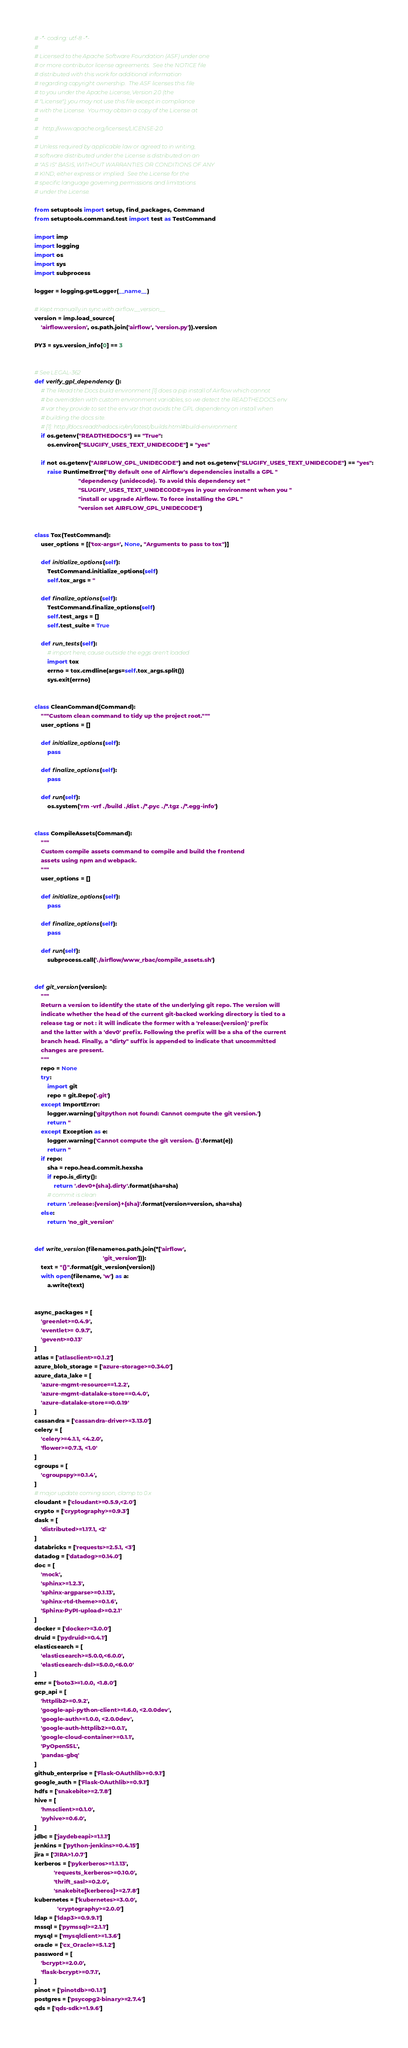<code> <loc_0><loc_0><loc_500><loc_500><_Python_># -*- coding: utf-8 -*-
#
# Licensed to the Apache Software Foundation (ASF) under one
# or more contributor license agreements.  See the NOTICE file
# distributed with this work for additional information
# regarding copyright ownership.  The ASF licenses this file
# to you under the Apache License, Version 2.0 (the
# "License"); you may not use this file except in compliance
# with the License.  You may obtain a copy of the License at
#
#   http://www.apache.org/licenses/LICENSE-2.0
#
# Unless required by applicable law or agreed to in writing,
# software distributed under the License is distributed on an
# "AS IS" BASIS, WITHOUT WARRANTIES OR CONDITIONS OF ANY
# KIND, either express or implied.  See the License for the
# specific language governing permissions and limitations
# under the License.

from setuptools import setup, find_packages, Command
from setuptools.command.test import test as TestCommand

import imp
import logging
import os
import sys
import subprocess

logger = logging.getLogger(__name__)

# Kept manually in sync with airflow.__version__
version = imp.load_source(
    'airflow.version', os.path.join('airflow', 'version.py')).version

PY3 = sys.version_info[0] == 3


# See LEGAL-362
def verify_gpl_dependency():
    # The Read the Docs build environment [1] does a pip install of Airflow which cannot
    # be overridden with custom environment variables, so we detect the READTHEDOCS env
    # var they provide to set the env var that avoids the GPL dependency on install when
    # building the docs site.
    # [1]: http://docs.readthedocs.io/en/latest/builds.html#build-environment
    if os.getenv("READTHEDOCS") == "True":
        os.environ["SLUGIFY_USES_TEXT_UNIDECODE"] = "yes"

    if not os.getenv("AIRFLOW_GPL_UNIDECODE") and not os.getenv("SLUGIFY_USES_TEXT_UNIDECODE") == "yes":
        raise RuntimeError("By default one of Airflow's dependencies installs a GPL "
                           "dependency (unidecode). To avoid this dependency set "
                           "SLUGIFY_USES_TEXT_UNIDECODE=yes in your environment when you "
                           "install or upgrade Airflow. To force installing the GPL "
                           "version set AIRFLOW_GPL_UNIDECODE")


class Tox(TestCommand):
    user_options = [('tox-args=', None, "Arguments to pass to tox")]

    def initialize_options(self):
        TestCommand.initialize_options(self)
        self.tox_args = ''

    def finalize_options(self):
        TestCommand.finalize_options(self)
        self.test_args = []
        self.test_suite = True

    def run_tests(self):
        # import here, cause outside the eggs aren't loaded
        import tox
        errno = tox.cmdline(args=self.tox_args.split())
        sys.exit(errno)


class CleanCommand(Command):
    """Custom clean command to tidy up the project root."""
    user_options = []

    def initialize_options(self):
        pass

    def finalize_options(self):
        pass

    def run(self):
        os.system('rm -vrf ./build ./dist ./*.pyc ./*.tgz ./*.egg-info')


class CompileAssets(Command):
    """
    Custom compile assets command to compile and build the frontend
    assets using npm and webpack.
    """
    user_options = []

    def initialize_options(self):
        pass

    def finalize_options(self):
        pass

    def run(self):
        subprocess.call('./airflow/www_rbac/compile_assets.sh')


def git_version(version):
    """
    Return a version to identify the state of the underlying git repo. The version will
    indicate whether the head of the current git-backed working directory is tied to a
    release tag or not : it will indicate the former with a 'release:{version}' prefix
    and the latter with a 'dev0' prefix. Following the prefix will be a sha of the current
    branch head. Finally, a "dirty" suffix is appended to indicate that uncommitted
    changes are present.
    """
    repo = None
    try:
        import git
        repo = git.Repo('.git')
    except ImportError:
        logger.warning('gitpython not found: Cannot compute the git version.')
        return ''
    except Exception as e:
        logger.warning('Cannot compute the git version. {}'.format(e))
        return ''
    if repo:
        sha = repo.head.commit.hexsha
        if repo.is_dirty():
            return '.dev0+{sha}.dirty'.format(sha=sha)
        # commit is clean
        return '.release:{version}+{sha}'.format(version=version, sha=sha)
    else:
        return 'no_git_version'


def write_version(filename=os.path.join(*['airflow',
                                          'git_version'])):
    text = "{}".format(git_version(version))
    with open(filename, 'w') as a:
        a.write(text)


async_packages = [
    'greenlet>=0.4.9',
    'eventlet>= 0.9.7',
    'gevent>=0.13'
]
atlas = ['atlasclient>=0.1.2']
azure_blob_storage = ['azure-storage>=0.34.0']
azure_data_lake = [
    'azure-mgmt-resource==1.2.2',
    'azure-mgmt-datalake-store==0.4.0',
    'azure-datalake-store==0.0.19'
]
cassandra = ['cassandra-driver>=3.13.0']
celery = [
    'celery>=4.1.1, <4.2.0',
    'flower>=0.7.3, <1.0'
]
cgroups = [
    'cgroupspy>=0.1.4',
]
# major update coming soon, clamp to 0.x
cloudant = ['cloudant>=0.5.9,<2.0']
crypto = ['cryptography>=0.9.3']
dask = [
    'distributed>=1.17.1, <2'
]
databricks = ['requests>=2.5.1, <3']
datadog = ['datadog>=0.14.0']
doc = [
    'mock',
    'sphinx>=1.2.3',
    'sphinx-argparse>=0.1.13',
    'sphinx-rtd-theme>=0.1.6',
    'Sphinx-PyPI-upload>=0.2.1'
]
docker = ['docker>=3.0.0']
druid = ['pydruid>=0.4.1']
elasticsearch = [
    'elasticsearch>=5.0.0,<6.0.0',
    'elasticsearch-dsl>=5.0.0,<6.0.0'
]
emr = ['boto3>=1.0.0, <1.8.0']
gcp_api = [
    'httplib2>=0.9.2',
    'google-api-python-client>=1.6.0, <2.0.0dev',
    'google-auth>=1.0.0, <2.0.0dev',
    'google-auth-httplib2>=0.0.1',
    'google-cloud-container>=0.1.1',
    'PyOpenSSL',
    'pandas-gbq'
]
github_enterprise = ['Flask-OAuthlib>=0.9.1']
google_auth = ['Flask-OAuthlib>=0.9.1']
hdfs = ['snakebite>=2.7.8']
hive = [
    'hmsclient>=0.1.0',
    'pyhive>=0.6.0',
]
jdbc = ['jaydebeapi>=1.1.1']
jenkins = ['python-jenkins>=0.4.15']
jira = ['JIRA>1.0.7']
kerberos = ['pykerberos>=1.1.13',
            'requests_kerberos>=0.10.0',
            'thrift_sasl>=0.2.0',
            'snakebite[kerberos]>=2.7.8']
kubernetes = ['kubernetes>=3.0.0',
              'cryptography>=2.0.0']
ldap = ['ldap3>=0.9.9.1']
mssql = ['pymssql>=2.1.1']
mysql = ['mysqlclient>=1.3.6']
oracle = ['cx_Oracle>=5.1.2']
password = [
    'bcrypt>=2.0.0',
    'flask-bcrypt>=0.7.1',
]
pinot = ['pinotdb>=0.1.1']
postgres = ['psycopg2-binary>=2.7.4']
qds = ['qds-sdk>=1.9.6']</code> 